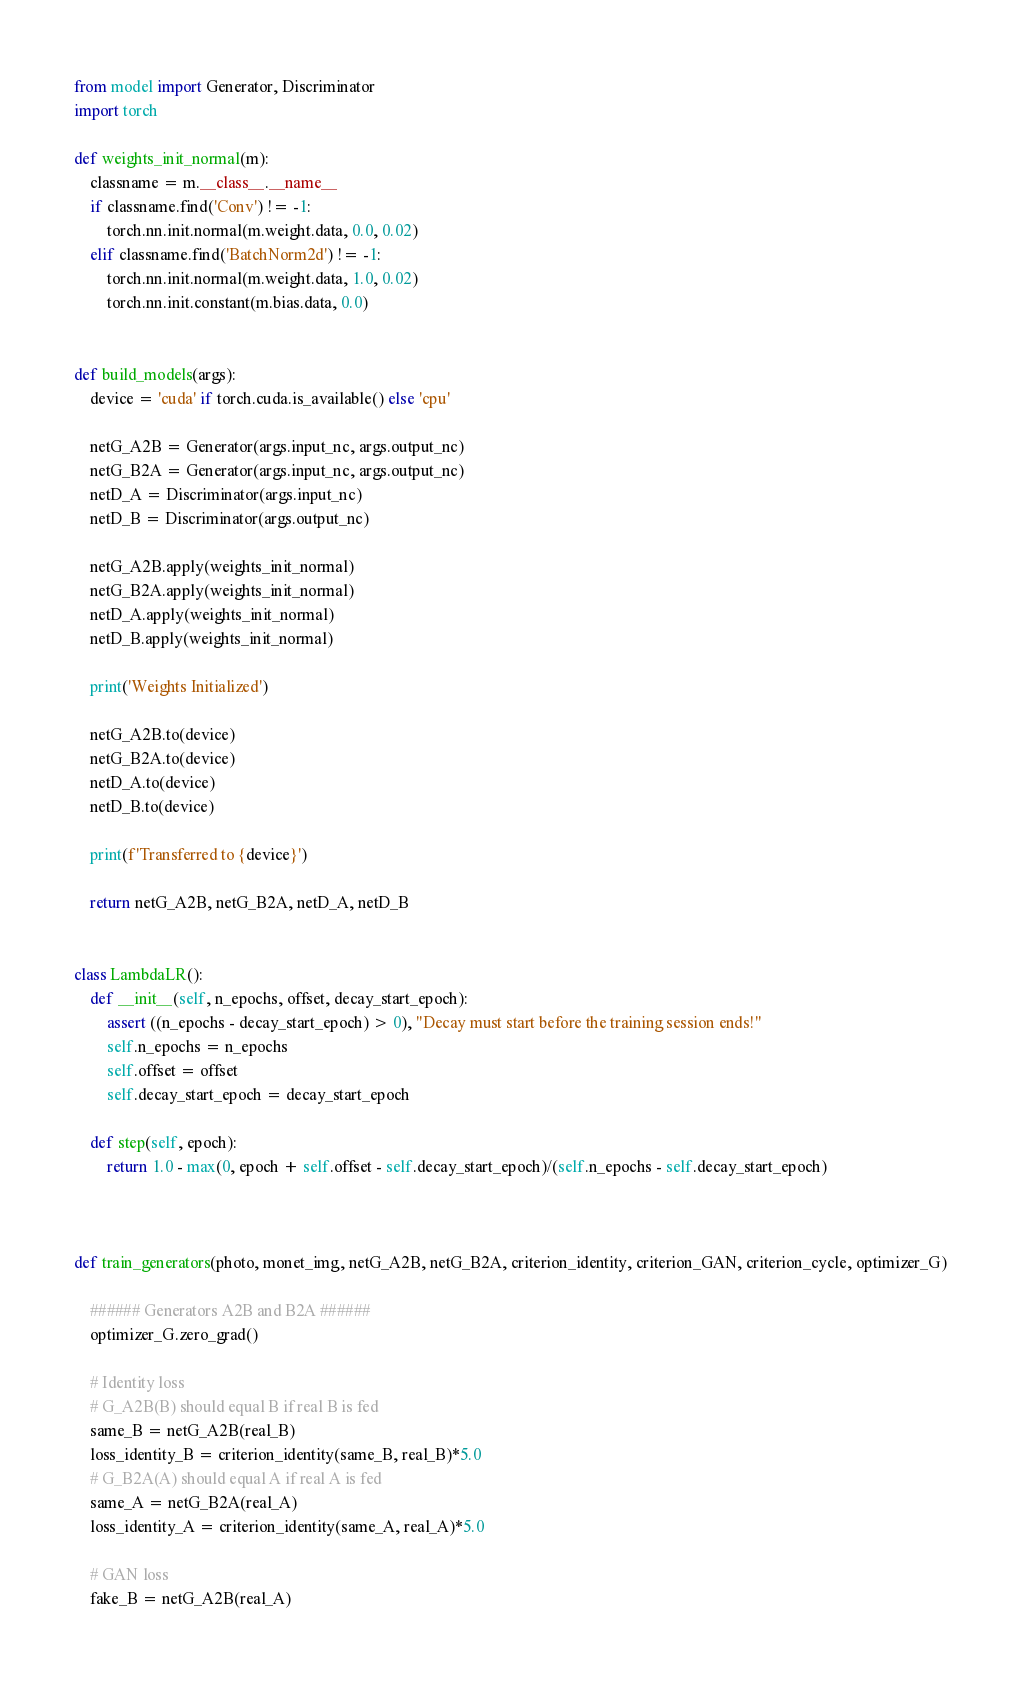<code> <loc_0><loc_0><loc_500><loc_500><_Python_>from model import Generator, Discriminator
import torch

def weights_init_normal(m):
    classname = m.__class__.__name__
    if classname.find('Conv') != -1:
        torch.nn.init.normal(m.weight.data, 0.0, 0.02)
    elif classname.find('BatchNorm2d') != -1:
        torch.nn.init.normal(m.weight.data, 1.0, 0.02)
        torch.nn.init.constant(m.bias.data, 0.0)


def build_models(args):
    device = 'cuda' if torch.cuda.is_available() else 'cpu'

    netG_A2B = Generator(args.input_nc, args.output_nc)
    netG_B2A = Generator(args.input_nc, args.output_nc)
    netD_A = Discriminator(args.input_nc)
    netD_B = Discriminator(args.output_nc)

    netG_A2B.apply(weights_init_normal)
    netG_B2A.apply(weights_init_normal)
    netD_A.apply(weights_init_normal)
    netD_B.apply(weights_init_normal)

    print('Weights Initialized')

    netG_A2B.to(device)
    netG_B2A.to(device)
    netD_A.to(device) 
    netD_B.to(device) 

    print(f'Transferred to {device}')

    return netG_A2B, netG_B2A, netD_A, netD_B


class LambdaLR():
    def __init__(self, n_epochs, offset, decay_start_epoch):
        assert ((n_epochs - decay_start_epoch) > 0), "Decay must start before the training session ends!"
        self.n_epochs = n_epochs
        self.offset = offset
        self.decay_start_epoch = decay_start_epoch

    def step(self, epoch):
        return 1.0 - max(0, epoch + self.offset - self.decay_start_epoch)/(self.n_epochs - self.decay_start_epoch)



def train_generators(photo, monet_img, netG_A2B, netG_B2A, criterion_identity, criterion_GAN, criterion_cycle, optimizer_G)

    ###### Generators A2B and B2A ######
    optimizer_G.zero_grad()

    # Identity loss
    # G_A2B(B) should equal B if real B is fed
    same_B = netG_A2B(real_B)
    loss_identity_B = criterion_identity(same_B, real_B)*5.0
    # G_B2A(A) should equal A if real A is fed
    same_A = netG_B2A(real_A)
    loss_identity_A = criterion_identity(same_A, real_A)*5.0

    # GAN loss
    fake_B = netG_A2B(real_A)</code> 